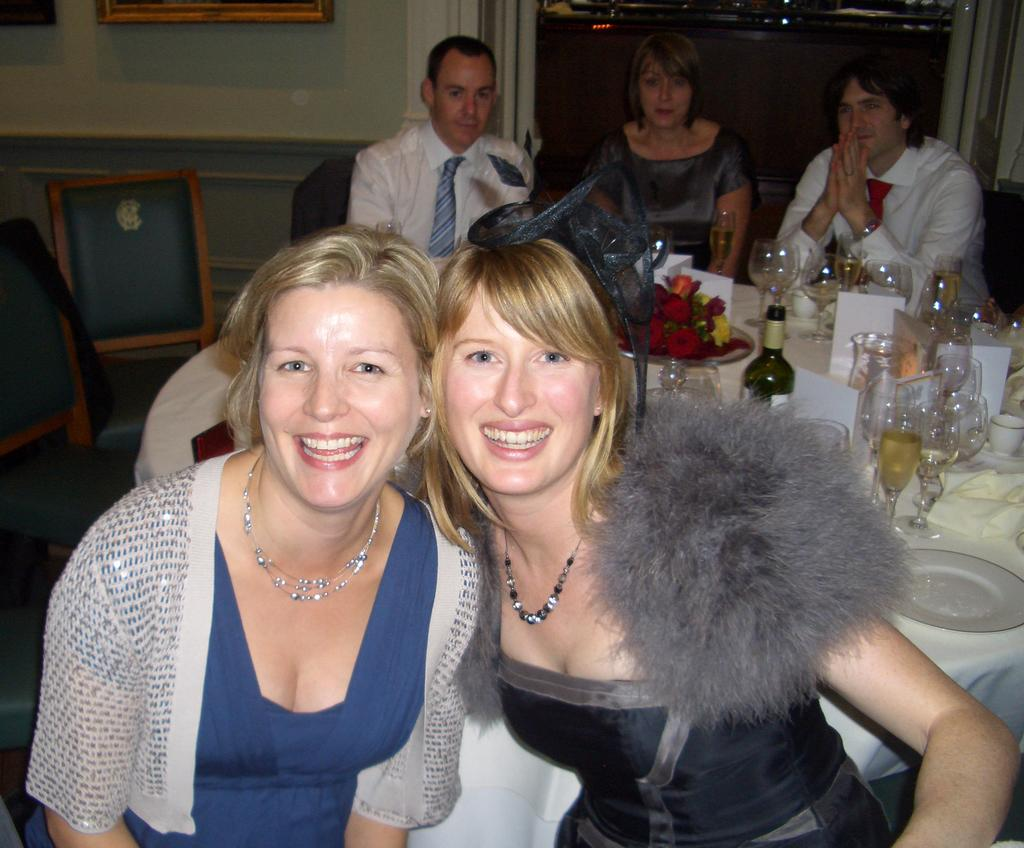How many girls are in the image? There are two beautiful girls in the image. What are the girls doing in the image? The girls are laughing. What can be seen in the background of the image? There is a dining table in the image. What objects are on the dining table? There are wine glasses on the dining table. What type of hen can be seen participating in the discussion with the girls in the image? There is no hen present in the image, nor is there any discussion taking place. 